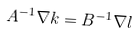<formula> <loc_0><loc_0><loc_500><loc_500>A ^ { - 1 } \nabla k = B ^ { - 1 } \nabla l</formula> 